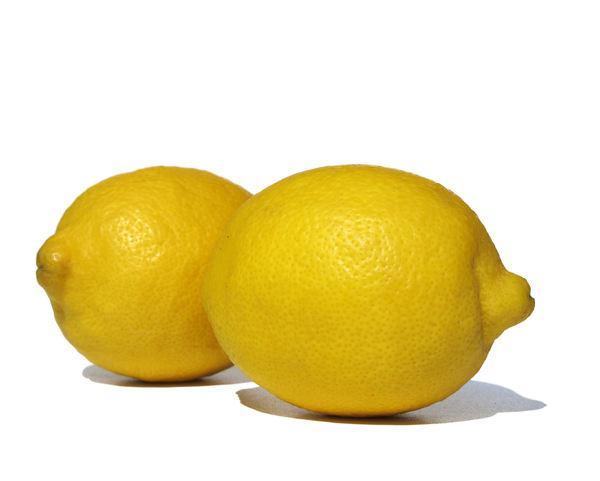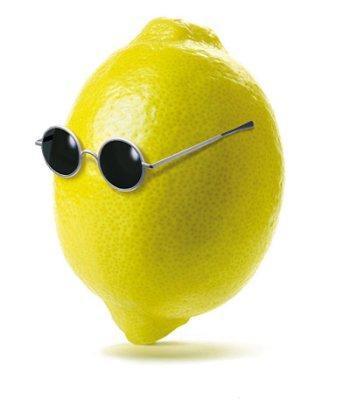The first image is the image on the left, the second image is the image on the right. Considering the images on both sides, is "An image contains exactly one whole lemon next to a lemon that is cut in half, and no green leaves are present." valid? Answer yes or no. No. The first image is the image on the left, the second image is the image on the right. Considering the images on both sides, is "The left image contain only two whole lemons." valid? Answer yes or no. Yes. 